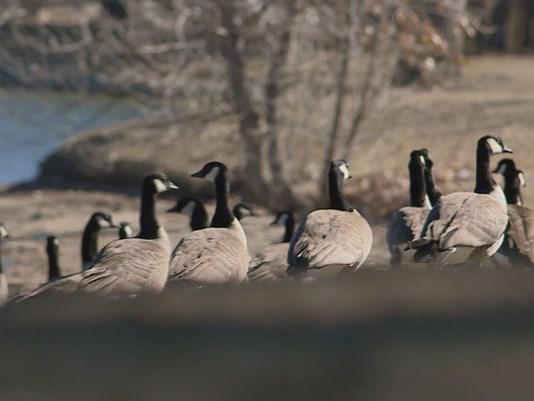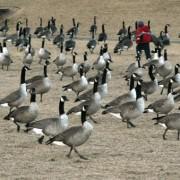The first image is the image on the left, the second image is the image on the right. Considering the images on both sides, is "There are geese visible on the water" valid? Answer yes or no. No. 